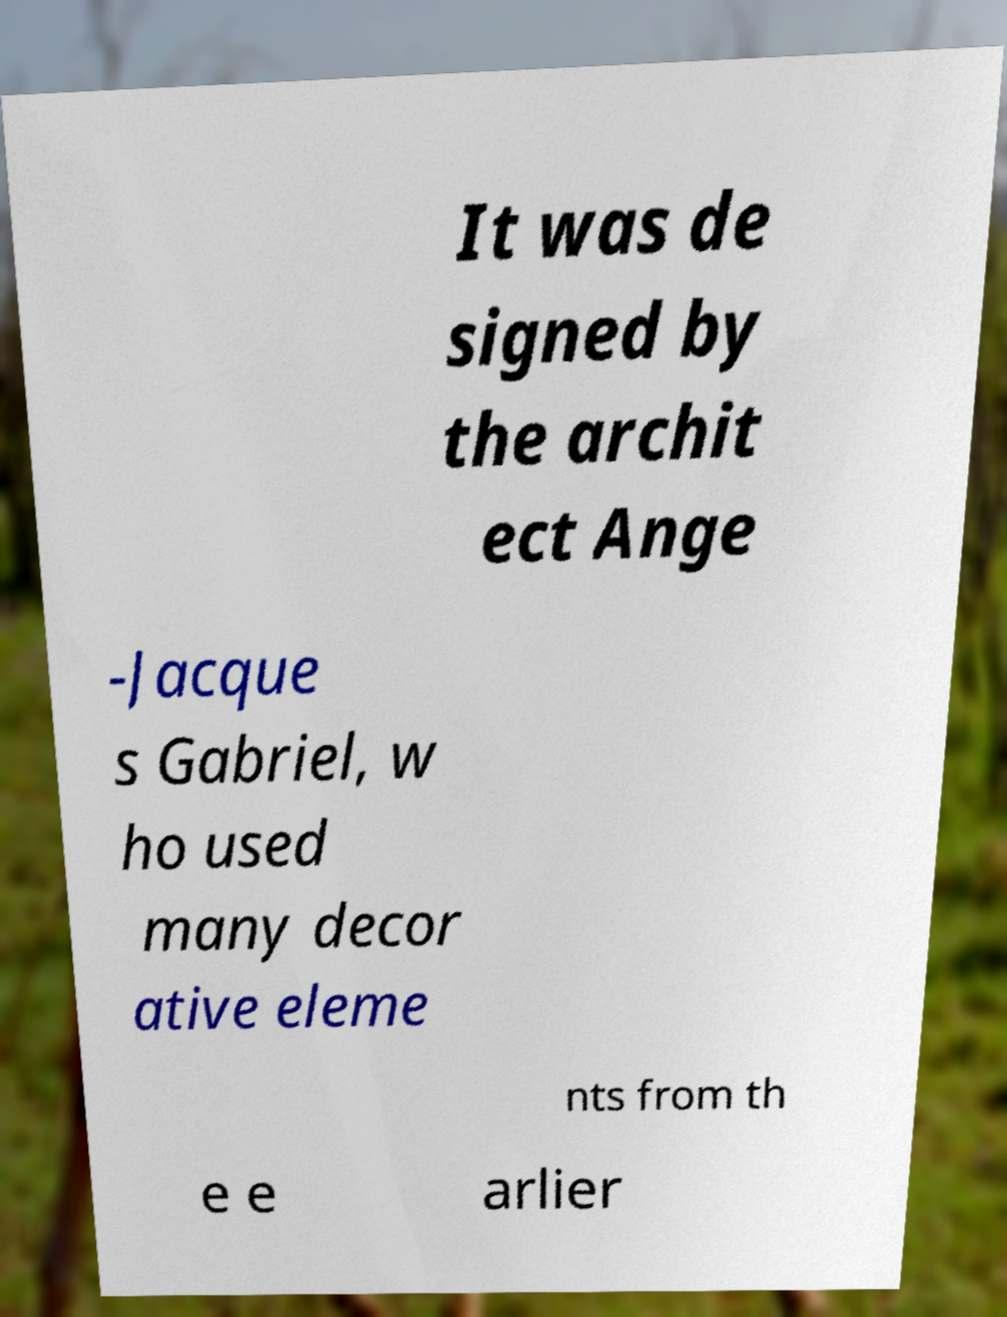For documentation purposes, I need the text within this image transcribed. Could you provide that? It was de signed by the archit ect Ange -Jacque s Gabriel, w ho used many decor ative eleme nts from th e e arlier 